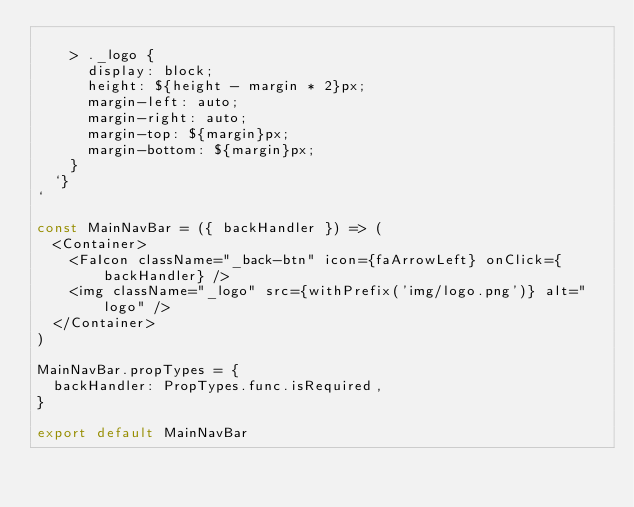<code> <loc_0><loc_0><loc_500><loc_500><_JavaScript_>
    > ._logo {
      display: block;
      height: ${height - margin * 2}px;
      margin-left: auto;
      margin-right: auto;
      margin-top: ${margin}px;
      margin-bottom: ${margin}px;
    }
  `}
`

const MainNavBar = ({ backHandler }) => (
  <Container>
    <FaIcon className="_back-btn" icon={faArrowLeft} onClick={backHandler} />
    <img className="_logo" src={withPrefix('img/logo.png')} alt="logo" />
  </Container>
)

MainNavBar.propTypes = {
  backHandler: PropTypes.func.isRequired,
}

export default MainNavBar
</code> 